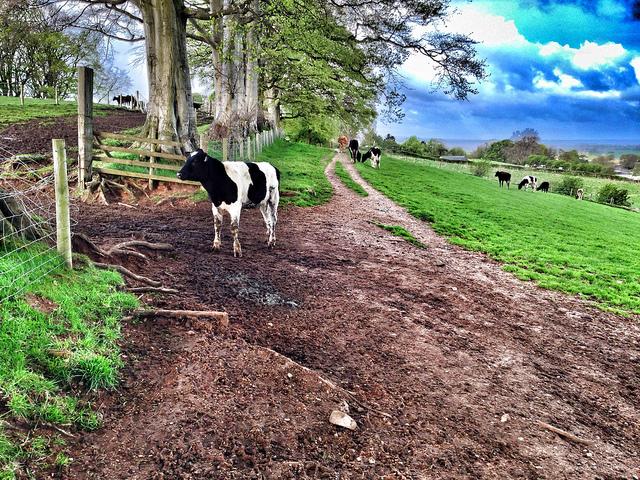What kind of animal is in the picture?
Short answer required. Cow. What are the cows in the picture doing?
Quick response, please. Grazing. Is this a real photo?
Answer briefly. Yes. How many cows?
Write a very short answer. 9. 